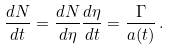<formula> <loc_0><loc_0><loc_500><loc_500>\frac { d N } { d t } = \frac { d N } { d \eta } \frac { d \eta } { d t } = \frac { \Gamma } { a ( t ) } \, .</formula> 